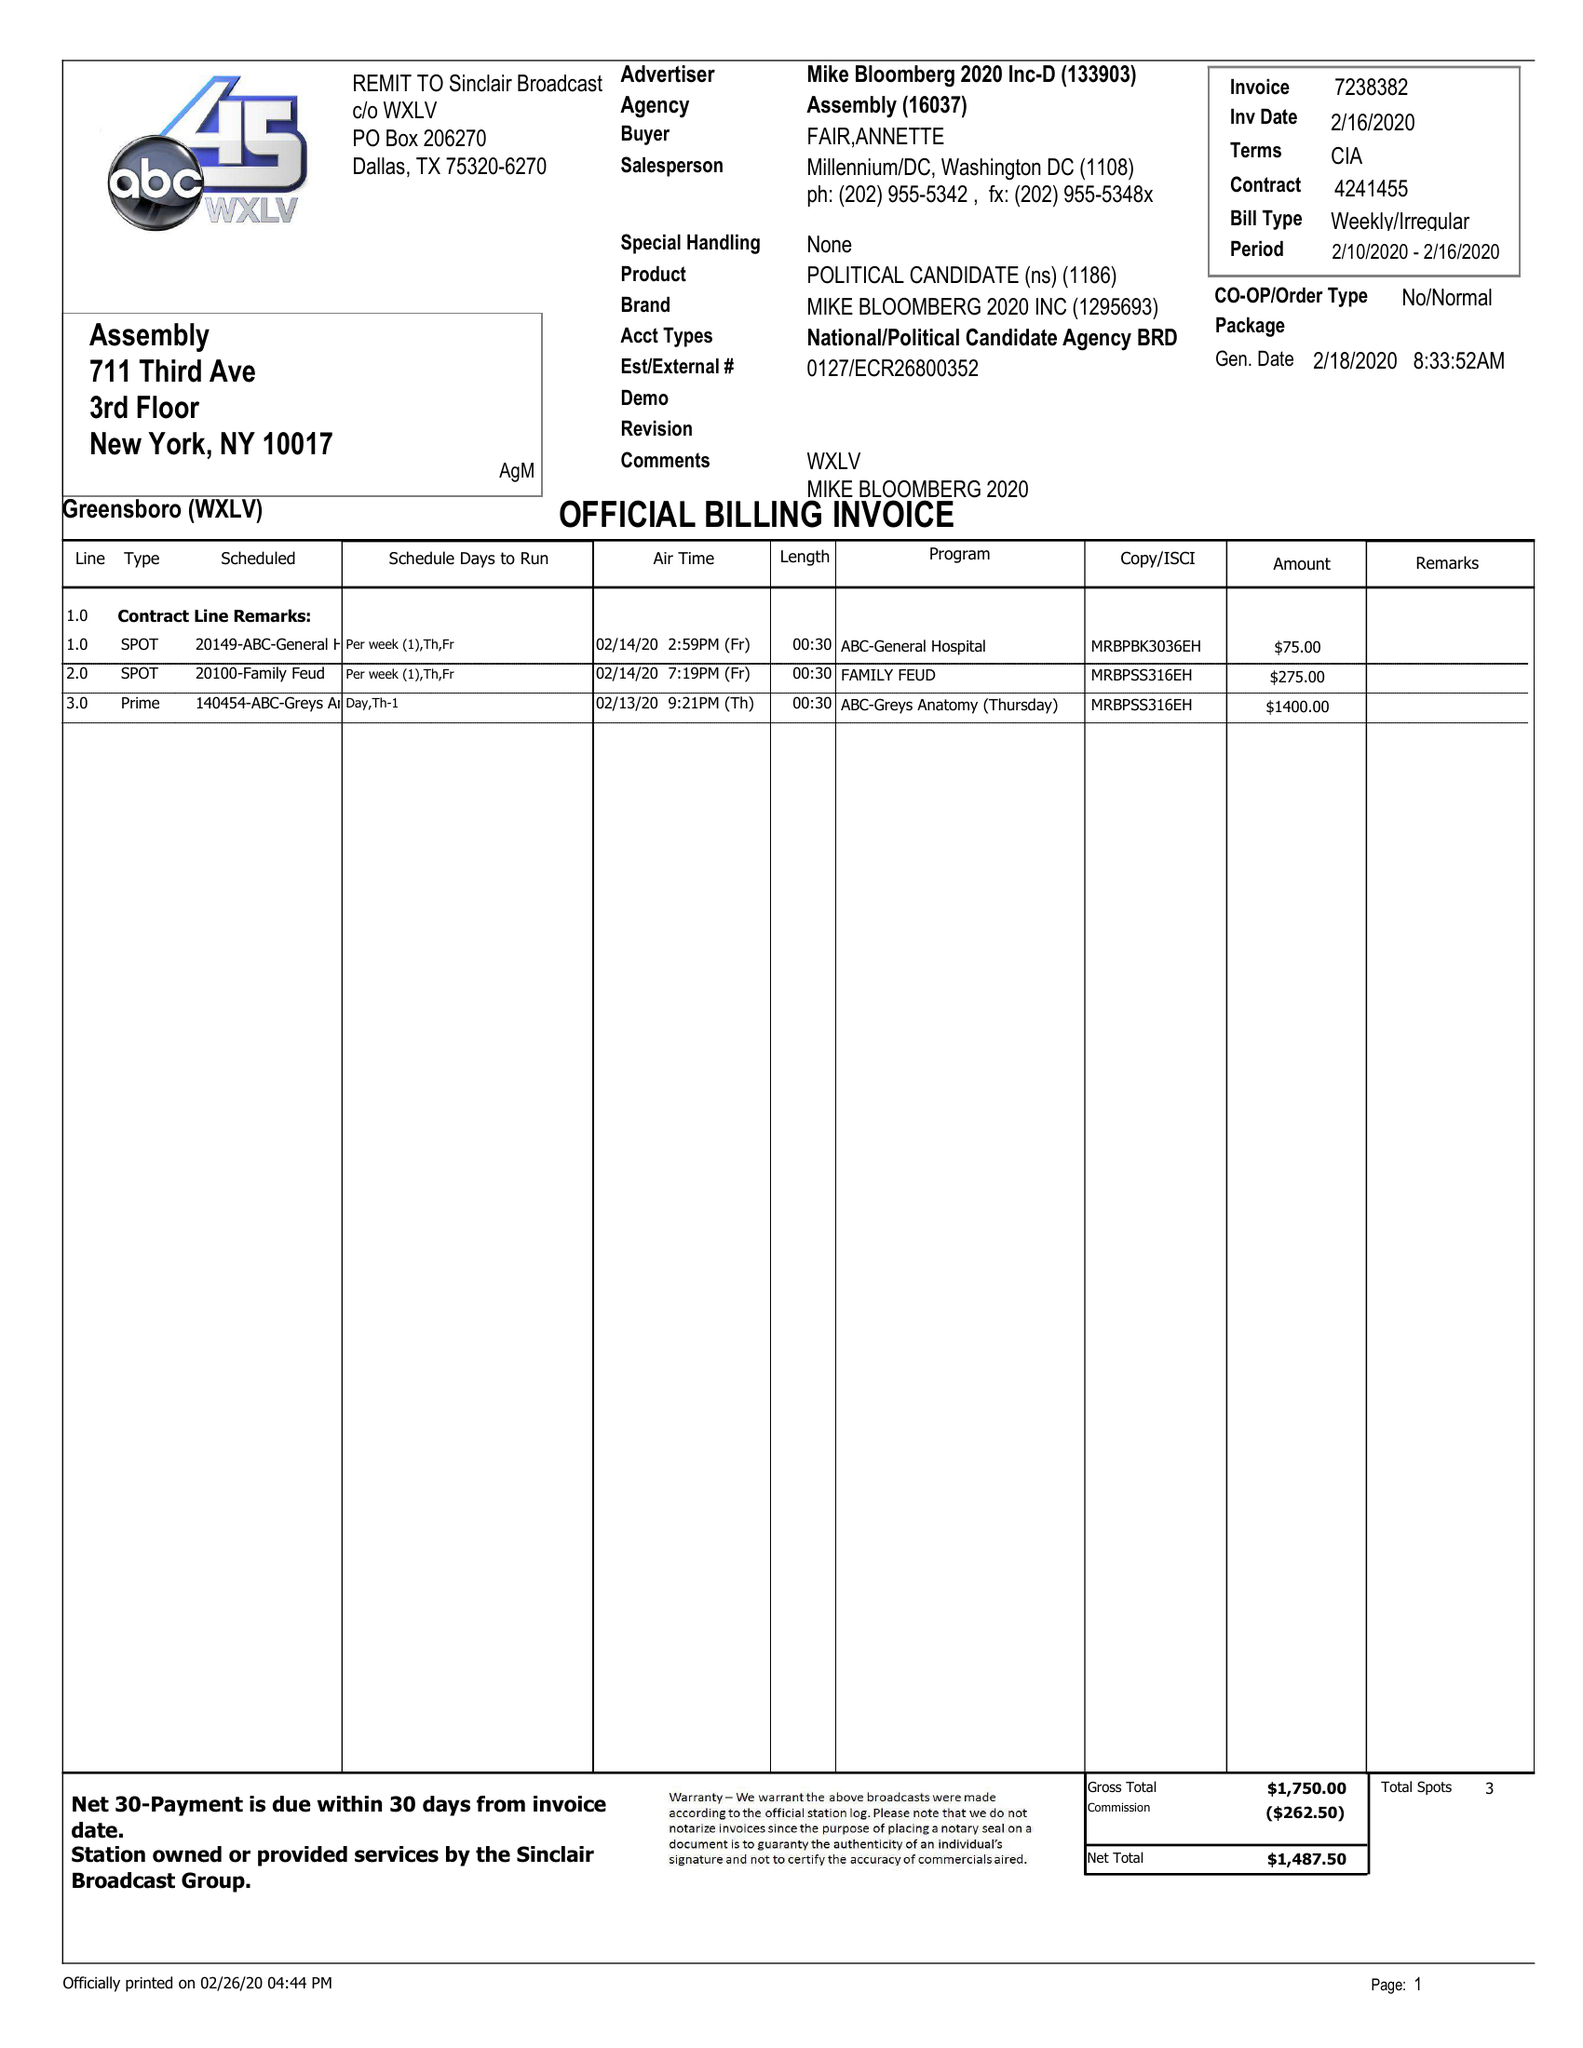What is the value for the advertiser?
Answer the question using a single word or phrase. MIKE BLOOMBERG 2020 INC-D 